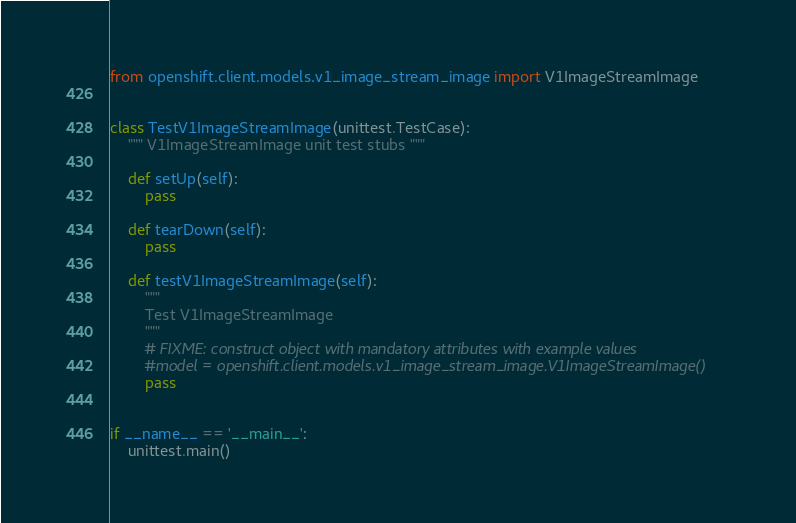<code> <loc_0><loc_0><loc_500><loc_500><_Python_>from openshift.client.models.v1_image_stream_image import V1ImageStreamImage


class TestV1ImageStreamImage(unittest.TestCase):
    """ V1ImageStreamImage unit test stubs """

    def setUp(self):
        pass

    def tearDown(self):
        pass

    def testV1ImageStreamImage(self):
        """
        Test V1ImageStreamImage
        """
        # FIXME: construct object with mandatory attributes with example values
        #model = openshift.client.models.v1_image_stream_image.V1ImageStreamImage()
        pass


if __name__ == '__main__':
    unittest.main()
</code> 